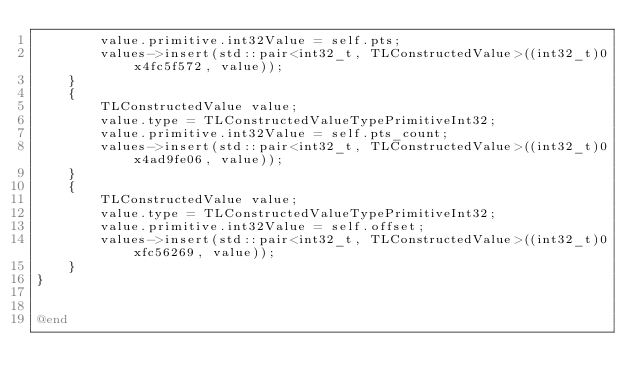Convert code to text. <code><loc_0><loc_0><loc_500><loc_500><_ObjectiveC_>        value.primitive.int32Value = self.pts;
        values->insert(std::pair<int32_t, TLConstructedValue>((int32_t)0x4fc5f572, value));
    }
    {
        TLConstructedValue value;
        value.type = TLConstructedValueTypePrimitiveInt32;
        value.primitive.int32Value = self.pts_count;
        values->insert(std::pair<int32_t, TLConstructedValue>((int32_t)0x4ad9fe06, value));
    }
    {
        TLConstructedValue value;
        value.type = TLConstructedValueTypePrimitiveInt32;
        value.primitive.int32Value = self.offset;
        values->insert(std::pair<int32_t, TLConstructedValue>((int32_t)0xfc56269, value));
    }
}


@end

</code> 